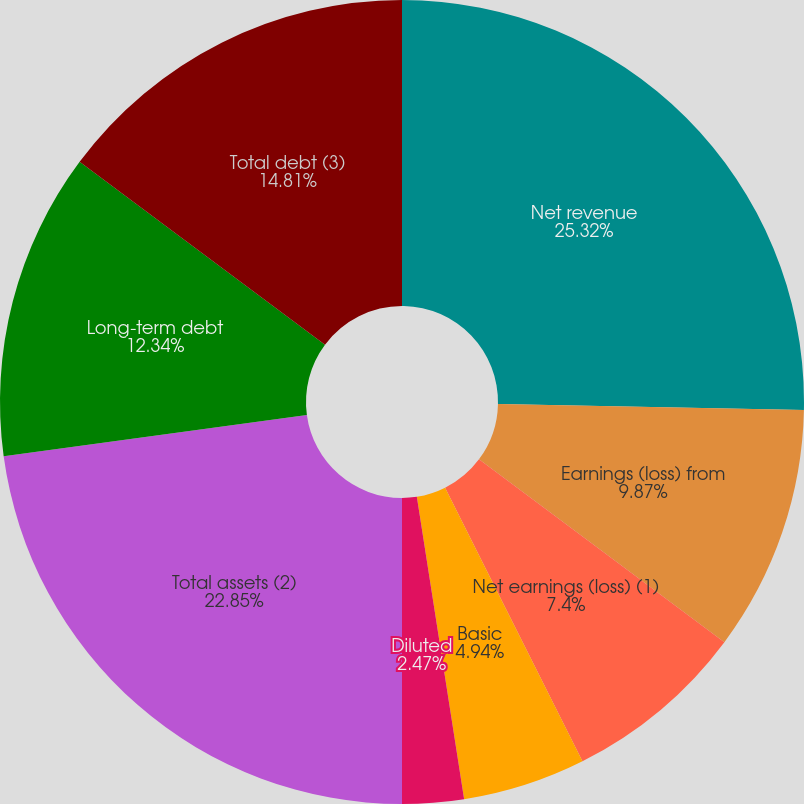Convert chart. <chart><loc_0><loc_0><loc_500><loc_500><pie_chart><fcel>Net revenue<fcel>Earnings (loss) from<fcel>Net earnings (loss) (1)<fcel>Basic<fcel>Diluted<fcel>Cash dividends declared per<fcel>Total assets (2)<fcel>Long-term debt<fcel>Total debt (3)<nl><fcel>25.32%<fcel>9.87%<fcel>7.4%<fcel>4.94%<fcel>2.47%<fcel>0.0%<fcel>22.85%<fcel>12.34%<fcel>14.81%<nl></chart> 